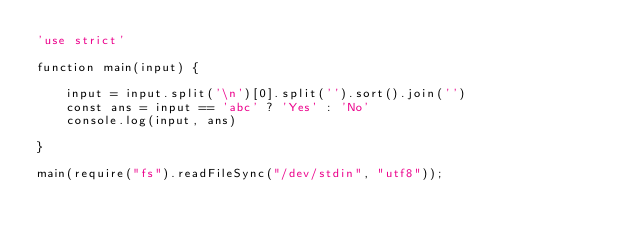<code> <loc_0><loc_0><loc_500><loc_500><_JavaScript_>'use strict'

function main(input) {

    input = input.split('\n')[0].split('').sort().join('')
    const ans = input == 'abc' ? 'Yes' : 'No'
    console.log(input, ans)

}

main(require("fs").readFileSync("/dev/stdin", "utf8"));</code> 